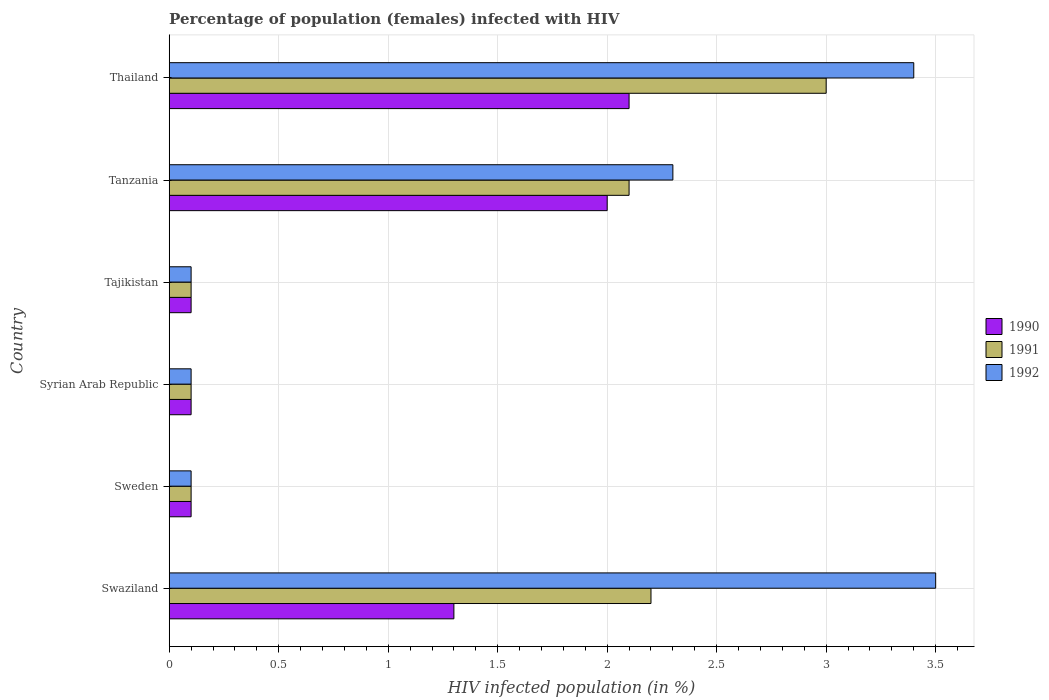Are the number of bars per tick equal to the number of legend labels?
Keep it short and to the point. Yes. What is the label of the 3rd group of bars from the top?
Your answer should be compact. Tajikistan. In which country was the percentage of HIV infected female population in 1991 maximum?
Your response must be concise. Thailand. In which country was the percentage of HIV infected female population in 1990 minimum?
Give a very brief answer. Sweden. What is the total percentage of HIV infected female population in 1992 in the graph?
Give a very brief answer. 9.5. What is the difference between the percentage of HIV infected female population in 1991 in Thailand and the percentage of HIV infected female population in 1992 in Tanzania?
Provide a short and direct response. 0.7. What is the average percentage of HIV infected female population in 1990 per country?
Your answer should be very brief. 0.95. In how many countries, is the percentage of HIV infected female population in 1992 greater than 1 %?
Make the answer very short. 3. Is the difference between the percentage of HIV infected female population in 1992 in Tajikistan and Thailand greater than the difference between the percentage of HIV infected female population in 1990 in Tajikistan and Thailand?
Provide a succinct answer. No. What is the difference between the highest and the second highest percentage of HIV infected female population in 1991?
Your answer should be compact. 0.8. What is the difference between the highest and the lowest percentage of HIV infected female population in 1992?
Your response must be concise. 3.4. Is the sum of the percentage of HIV infected female population in 1992 in Sweden and Tanzania greater than the maximum percentage of HIV infected female population in 1991 across all countries?
Make the answer very short. No. What does the 3rd bar from the top in Tajikistan represents?
Your response must be concise. 1990. What does the 1st bar from the bottom in Swaziland represents?
Make the answer very short. 1990. Are all the bars in the graph horizontal?
Your answer should be compact. Yes. How many countries are there in the graph?
Provide a short and direct response. 6. What is the difference between two consecutive major ticks on the X-axis?
Ensure brevity in your answer.  0.5. Are the values on the major ticks of X-axis written in scientific E-notation?
Make the answer very short. No. How many legend labels are there?
Your answer should be very brief. 3. What is the title of the graph?
Ensure brevity in your answer.  Percentage of population (females) infected with HIV. Does "2003" appear as one of the legend labels in the graph?
Your response must be concise. No. What is the label or title of the X-axis?
Offer a terse response. HIV infected population (in %). What is the label or title of the Y-axis?
Your answer should be very brief. Country. What is the HIV infected population (in %) in 1990 in Swaziland?
Your response must be concise. 1.3. What is the HIV infected population (in %) of 1992 in Swaziland?
Provide a succinct answer. 3.5. What is the HIV infected population (in %) of 1991 in Sweden?
Your answer should be compact. 0.1. What is the HIV infected population (in %) in 1992 in Sweden?
Make the answer very short. 0.1. What is the HIV infected population (in %) of 1990 in Tajikistan?
Provide a short and direct response. 0.1. What is the HIV infected population (in %) in 1991 in Tajikistan?
Offer a terse response. 0.1. What is the HIV infected population (in %) in 1992 in Tajikistan?
Keep it short and to the point. 0.1. What is the HIV infected population (in %) in 1990 in Tanzania?
Your answer should be very brief. 2. What is the HIV infected population (in %) of 1991 in Tanzania?
Keep it short and to the point. 2.1. What is the HIV infected population (in %) of 1990 in Thailand?
Your answer should be very brief. 2.1. Across all countries, what is the maximum HIV infected population (in %) of 1990?
Provide a succinct answer. 2.1. Across all countries, what is the maximum HIV infected population (in %) in 1992?
Offer a terse response. 3.5. Across all countries, what is the minimum HIV infected population (in %) in 1991?
Provide a succinct answer. 0.1. What is the total HIV infected population (in %) of 1990 in the graph?
Provide a short and direct response. 5.7. What is the total HIV infected population (in %) in 1992 in the graph?
Offer a very short reply. 9.5. What is the difference between the HIV infected population (in %) in 1991 in Swaziland and that in Sweden?
Provide a succinct answer. 2.1. What is the difference between the HIV infected population (in %) of 1992 in Swaziland and that in Sweden?
Provide a succinct answer. 3.4. What is the difference between the HIV infected population (in %) in 1991 in Swaziland and that in Tajikistan?
Your response must be concise. 2.1. What is the difference between the HIV infected population (in %) in 1992 in Swaziland and that in Tajikistan?
Give a very brief answer. 3.4. What is the difference between the HIV infected population (in %) in 1990 in Swaziland and that in Tanzania?
Your response must be concise. -0.7. What is the difference between the HIV infected population (in %) of 1991 in Swaziland and that in Tanzania?
Your answer should be very brief. 0.1. What is the difference between the HIV infected population (in %) of 1990 in Swaziland and that in Thailand?
Offer a terse response. -0.8. What is the difference between the HIV infected population (in %) of 1991 in Swaziland and that in Thailand?
Ensure brevity in your answer.  -0.8. What is the difference between the HIV infected population (in %) in 1992 in Swaziland and that in Thailand?
Give a very brief answer. 0.1. What is the difference between the HIV infected population (in %) in 1990 in Sweden and that in Syrian Arab Republic?
Offer a terse response. 0. What is the difference between the HIV infected population (in %) of 1991 in Sweden and that in Tajikistan?
Offer a terse response. 0. What is the difference between the HIV infected population (in %) in 1992 in Sweden and that in Tajikistan?
Offer a very short reply. 0. What is the difference between the HIV infected population (in %) of 1991 in Sweden and that in Thailand?
Keep it short and to the point. -2.9. What is the difference between the HIV infected population (in %) of 1991 in Syrian Arab Republic and that in Tajikistan?
Provide a succinct answer. 0. What is the difference between the HIV infected population (in %) in 1992 in Syrian Arab Republic and that in Tajikistan?
Offer a very short reply. 0. What is the difference between the HIV infected population (in %) in 1990 in Syrian Arab Republic and that in Tanzania?
Offer a very short reply. -1.9. What is the difference between the HIV infected population (in %) of 1992 in Syrian Arab Republic and that in Thailand?
Offer a terse response. -3.3. What is the difference between the HIV infected population (in %) in 1990 in Tajikistan and that in Tanzania?
Provide a succinct answer. -1.9. What is the difference between the HIV infected population (in %) of 1991 in Tajikistan and that in Tanzania?
Your response must be concise. -2. What is the difference between the HIV infected population (in %) of 1990 in Tajikistan and that in Thailand?
Offer a terse response. -2. What is the difference between the HIV infected population (in %) of 1992 in Tajikistan and that in Thailand?
Make the answer very short. -3.3. What is the difference between the HIV infected population (in %) of 1990 in Tanzania and that in Thailand?
Your response must be concise. -0.1. What is the difference between the HIV infected population (in %) in 1991 in Swaziland and the HIV infected population (in %) in 1992 in Sweden?
Ensure brevity in your answer.  2.1. What is the difference between the HIV infected population (in %) of 1990 in Swaziland and the HIV infected population (in %) of 1992 in Syrian Arab Republic?
Provide a succinct answer. 1.2. What is the difference between the HIV infected population (in %) in 1990 in Swaziland and the HIV infected population (in %) in 1992 in Tajikistan?
Your response must be concise. 1.2. What is the difference between the HIV infected population (in %) in 1991 in Swaziland and the HIV infected population (in %) in 1992 in Tajikistan?
Your answer should be compact. 2.1. What is the difference between the HIV infected population (in %) of 1990 in Swaziland and the HIV infected population (in %) of 1991 in Tanzania?
Ensure brevity in your answer.  -0.8. What is the difference between the HIV infected population (in %) in 1990 in Swaziland and the HIV infected population (in %) in 1992 in Tanzania?
Ensure brevity in your answer.  -1. What is the difference between the HIV infected population (in %) in 1991 in Swaziland and the HIV infected population (in %) in 1992 in Tanzania?
Your answer should be very brief. -0.1. What is the difference between the HIV infected population (in %) of 1990 in Sweden and the HIV infected population (in %) of 1991 in Syrian Arab Republic?
Offer a very short reply. 0. What is the difference between the HIV infected population (in %) in 1991 in Sweden and the HIV infected population (in %) in 1992 in Syrian Arab Republic?
Give a very brief answer. 0. What is the difference between the HIV infected population (in %) in 1990 in Sweden and the HIV infected population (in %) in 1991 in Tajikistan?
Keep it short and to the point. 0. What is the difference between the HIV infected population (in %) in 1990 in Sweden and the HIV infected population (in %) in 1992 in Tajikistan?
Keep it short and to the point. 0. What is the difference between the HIV infected population (in %) in 1991 in Sweden and the HIV infected population (in %) in 1992 in Tajikistan?
Provide a succinct answer. 0. What is the difference between the HIV infected population (in %) in 1991 in Sweden and the HIV infected population (in %) in 1992 in Tanzania?
Ensure brevity in your answer.  -2.2. What is the difference between the HIV infected population (in %) of 1990 in Sweden and the HIV infected population (in %) of 1992 in Thailand?
Make the answer very short. -3.3. What is the difference between the HIV infected population (in %) in 1990 in Syrian Arab Republic and the HIV infected population (in %) in 1991 in Tajikistan?
Provide a succinct answer. 0. What is the difference between the HIV infected population (in %) in 1990 in Syrian Arab Republic and the HIV infected population (in %) in 1992 in Tajikistan?
Offer a very short reply. 0. What is the difference between the HIV infected population (in %) of 1990 in Syrian Arab Republic and the HIV infected population (in %) of 1992 in Tanzania?
Offer a terse response. -2.2. What is the difference between the HIV infected population (in %) of 1991 in Syrian Arab Republic and the HIV infected population (in %) of 1992 in Thailand?
Offer a terse response. -3.3. What is the difference between the HIV infected population (in %) of 1990 in Tajikistan and the HIV infected population (in %) of 1991 in Tanzania?
Offer a terse response. -2. What is the difference between the HIV infected population (in %) of 1991 in Tajikistan and the HIV infected population (in %) of 1992 in Tanzania?
Your answer should be very brief. -2.2. What is the difference between the HIV infected population (in %) of 1990 in Tajikistan and the HIV infected population (in %) of 1992 in Thailand?
Provide a short and direct response. -3.3. What is the difference between the HIV infected population (in %) in 1990 in Tanzania and the HIV infected population (in %) in 1991 in Thailand?
Provide a succinct answer. -1. What is the average HIV infected population (in %) of 1991 per country?
Offer a very short reply. 1.27. What is the average HIV infected population (in %) of 1992 per country?
Offer a very short reply. 1.58. What is the difference between the HIV infected population (in %) in 1990 and HIV infected population (in %) in 1991 in Swaziland?
Keep it short and to the point. -0.9. What is the difference between the HIV infected population (in %) of 1990 and HIV infected population (in %) of 1991 in Sweden?
Provide a succinct answer. 0. What is the difference between the HIV infected population (in %) of 1990 and HIV infected population (in %) of 1992 in Sweden?
Keep it short and to the point. 0. What is the difference between the HIV infected population (in %) in 1990 and HIV infected population (in %) in 1991 in Syrian Arab Republic?
Give a very brief answer. 0. What is the difference between the HIV infected population (in %) in 1991 and HIV infected population (in %) in 1992 in Syrian Arab Republic?
Provide a succinct answer. 0. What is the difference between the HIV infected population (in %) of 1990 and HIV infected population (in %) of 1991 in Tajikistan?
Give a very brief answer. 0. What is the difference between the HIV infected population (in %) of 1990 and HIV infected population (in %) of 1992 in Tajikistan?
Your answer should be compact. 0. What is the difference between the HIV infected population (in %) of 1991 and HIV infected population (in %) of 1992 in Tajikistan?
Offer a terse response. 0. What is the difference between the HIV infected population (in %) of 1990 and HIV infected population (in %) of 1991 in Tanzania?
Ensure brevity in your answer.  -0.1. What is the difference between the HIV infected population (in %) in 1990 and HIV infected population (in %) in 1992 in Thailand?
Keep it short and to the point. -1.3. What is the difference between the HIV infected population (in %) of 1991 and HIV infected population (in %) of 1992 in Thailand?
Give a very brief answer. -0.4. What is the ratio of the HIV infected population (in %) in 1991 in Swaziland to that in Sweden?
Offer a very short reply. 22. What is the ratio of the HIV infected population (in %) of 1990 in Swaziland to that in Syrian Arab Republic?
Your answer should be very brief. 13. What is the ratio of the HIV infected population (in %) in 1992 in Swaziland to that in Syrian Arab Republic?
Provide a succinct answer. 35. What is the ratio of the HIV infected population (in %) of 1990 in Swaziland to that in Tajikistan?
Offer a terse response. 13. What is the ratio of the HIV infected population (in %) of 1992 in Swaziland to that in Tajikistan?
Offer a very short reply. 35. What is the ratio of the HIV infected population (in %) of 1990 in Swaziland to that in Tanzania?
Your answer should be very brief. 0.65. What is the ratio of the HIV infected population (in %) in 1991 in Swaziland to that in Tanzania?
Keep it short and to the point. 1.05. What is the ratio of the HIV infected population (in %) of 1992 in Swaziland to that in Tanzania?
Make the answer very short. 1.52. What is the ratio of the HIV infected population (in %) in 1990 in Swaziland to that in Thailand?
Provide a short and direct response. 0.62. What is the ratio of the HIV infected population (in %) of 1991 in Swaziland to that in Thailand?
Ensure brevity in your answer.  0.73. What is the ratio of the HIV infected population (in %) in 1992 in Swaziland to that in Thailand?
Ensure brevity in your answer.  1.03. What is the ratio of the HIV infected population (in %) of 1990 in Sweden to that in Syrian Arab Republic?
Offer a terse response. 1. What is the ratio of the HIV infected population (in %) of 1991 in Sweden to that in Syrian Arab Republic?
Ensure brevity in your answer.  1. What is the ratio of the HIV infected population (in %) of 1992 in Sweden to that in Syrian Arab Republic?
Keep it short and to the point. 1. What is the ratio of the HIV infected population (in %) in 1991 in Sweden to that in Tanzania?
Provide a short and direct response. 0.05. What is the ratio of the HIV infected population (in %) of 1992 in Sweden to that in Tanzania?
Provide a succinct answer. 0.04. What is the ratio of the HIV infected population (in %) in 1990 in Sweden to that in Thailand?
Your answer should be compact. 0.05. What is the ratio of the HIV infected population (in %) of 1992 in Sweden to that in Thailand?
Provide a short and direct response. 0.03. What is the ratio of the HIV infected population (in %) in 1991 in Syrian Arab Republic to that in Tajikistan?
Make the answer very short. 1. What is the ratio of the HIV infected population (in %) in 1990 in Syrian Arab Republic to that in Tanzania?
Your answer should be very brief. 0.05. What is the ratio of the HIV infected population (in %) in 1991 in Syrian Arab Republic to that in Tanzania?
Provide a succinct answer. 0.05. What is the ratio of the HIV infected population (in %) of 1992 in Syrian Arab Republic to that in Tanzania?
Your answer should be compact. 0.04. What is the ratio of the HIV infected population (in %) of 1990 in Syrian Arab Republic to that in Thailand?
Your response must be concise. 0.05. What is the ratio of the HIV infected population (in %) of 1991 in Syrian Arab Republic to that in Thailand?
Offer a very short reply. 0.03. What is the ratio of the HIV infected population (in %) of 1992 in Syrian Arab Republic to that in Thailand?
Offer a very short reply. 0.03. What is the ratio of the HIV infected population (in %) in 1991 in Tajikistan to that in Tanzania?
Offer a terse response. 0.05. What is the ratio of the HIV infected population (in %) of 1992 in Tajikistan to that in Tanzania?
Offer a terse response. 0.04. What is the ratio of the HIV infected population (in %) of 1990 in Tajikistan to that in Thailand?
Make the answer very short. 0.05. What is the ratio of the HIV infected population (in %) of 1992 in Tajikistan to that in Thailand?
Give a very brief answer. 0.03. What is the ratio of the HIV infected population (in %) in 1990 in Tanzania to that in Thailand?
Provide a short and direct response. 0.95. What is the ratio of the HIV infected population (in %) of 1992 in Tanzania to that in Thailand?
Ensure brevity in your answer.  0.68. What is the difference between the highest and the second highest HIV infected population (in %) in 1992?
Offer a very short reply. 0.1. What is the difference between the highest and the lowest HIV infected population (in %) in 1992?
Your response must be concise. 3.4. 